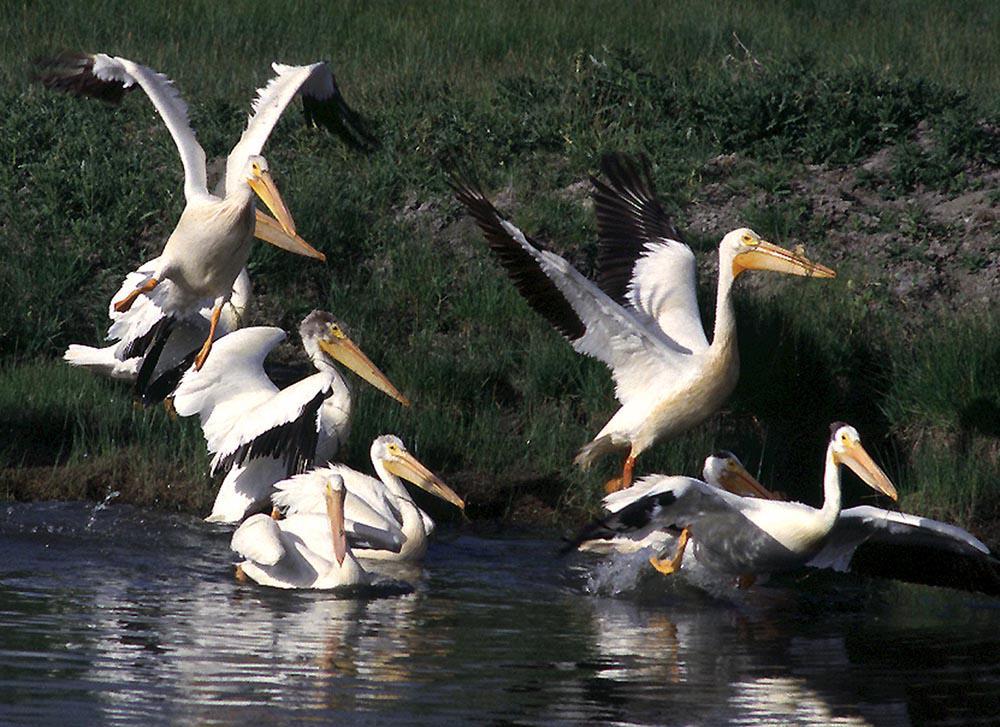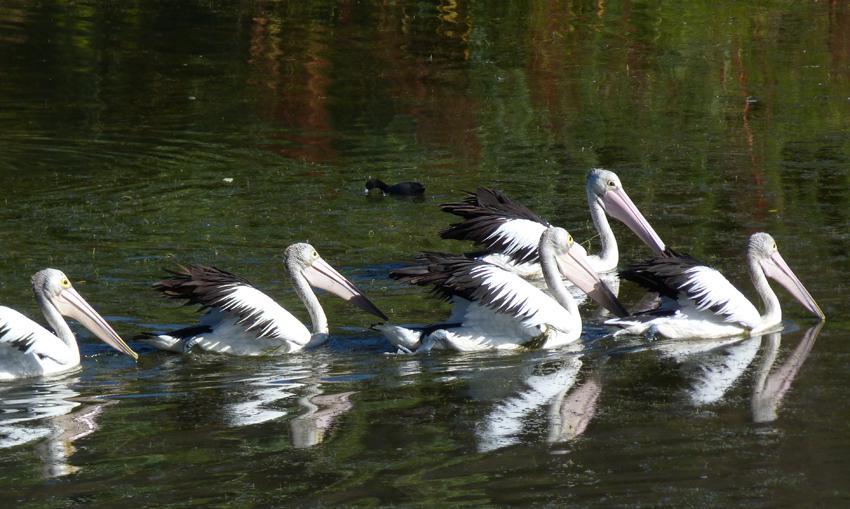The first image is the image on the left, the second image is the image on the right. For the images displayed, is the sentence "There is only one bird in one of the images." factually correct? Answer yes or no. No. The first image is the image on the left, the second image is the image on the right. For the images shown, is this caption "there is one bird in the right side photo" true? Answer yes or no. No. 